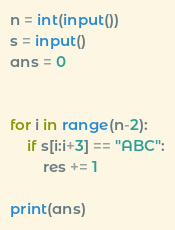<code> <loc_0><loc_0><loc_500><loc_500><_Python_>n = int(input())
s = input()
ans = 0


for i in range(n-2):
    if s[i:i+3] == "ABC":
        res += 1

print(ans)</code> 